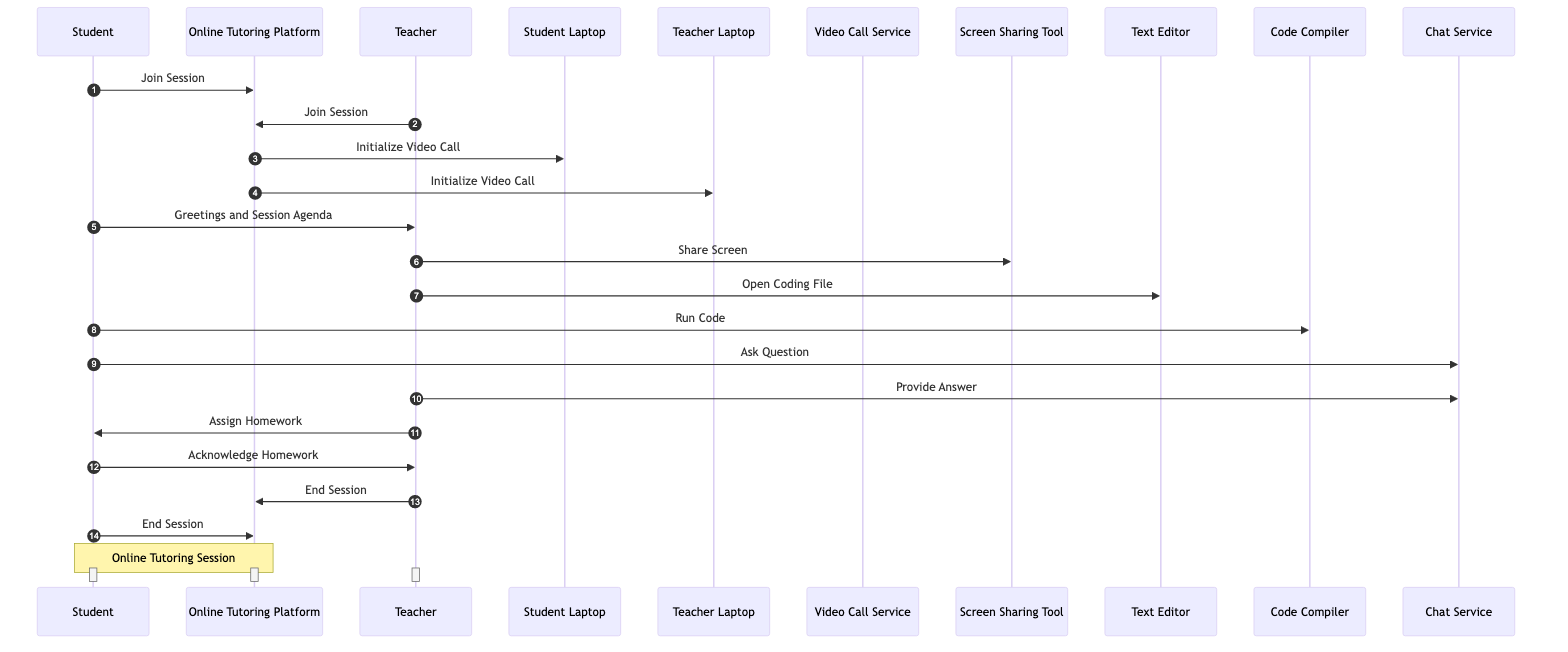What are the actors involved in the sequence diagram? The actors are explicitly listed at the beginning of the diagram as Student, Teacher, and Online Tutoring Platform.
Answer: Student, Teacher, Online Tutoring Platform How many interactions are there in total? By counting each message exchanged between the participants, there are a total of 14 interactions in the sequence diagram.
Answer: 14 Who is the first participant to send a message? The first message is sent from the Student to the Online Tutoring Platform with the content "Join Session", making Student the first participant.
Answer: Student Which tool does the Teacher use to share their screen? The Teacher sends a message to the Screen Sharing Tool to perform the action "Share Screen", indicating that this is the tool used for that purpose.
Answer: Screen Sharing Tool What message is exchanged after the Teacher assigns homework? After the Teacher assigns homework, the next message sent is from the Student acknowledging the homework, thus the specific message exchanged is "Acknowledge Homework".
Answer: Acknowledge Homework What is the last interaction in the sequence diagram? The last interaction occurs when both the Teacher and Student send messages to the Online Tutoring Platform to end the session, with the Teacher being one of the last two participants sending an "End Session".
Answer: End Session How many tools are used in the sequence diagram? The tools involved in the interactions are Student Laptop, Teacher Laptop, Video Call Service, Screen Sharing Tool, Text Editor, Code Compiler, and Chat Service, amounting to 7 tools in total.
Answer: 7 Which participant communicates directly with the Chat Service? Both the Student and Teacher communicate with the Chat Service, but the Student initiates the communication first by asking a question.
Answer: Student, Teacher What action does the Student take immediately after the Teacher shares their screen? After the Teacher shares their screen, the Student runs the code using the Code Compiler, making it the immediate action that follows.
Answer: Run Code 